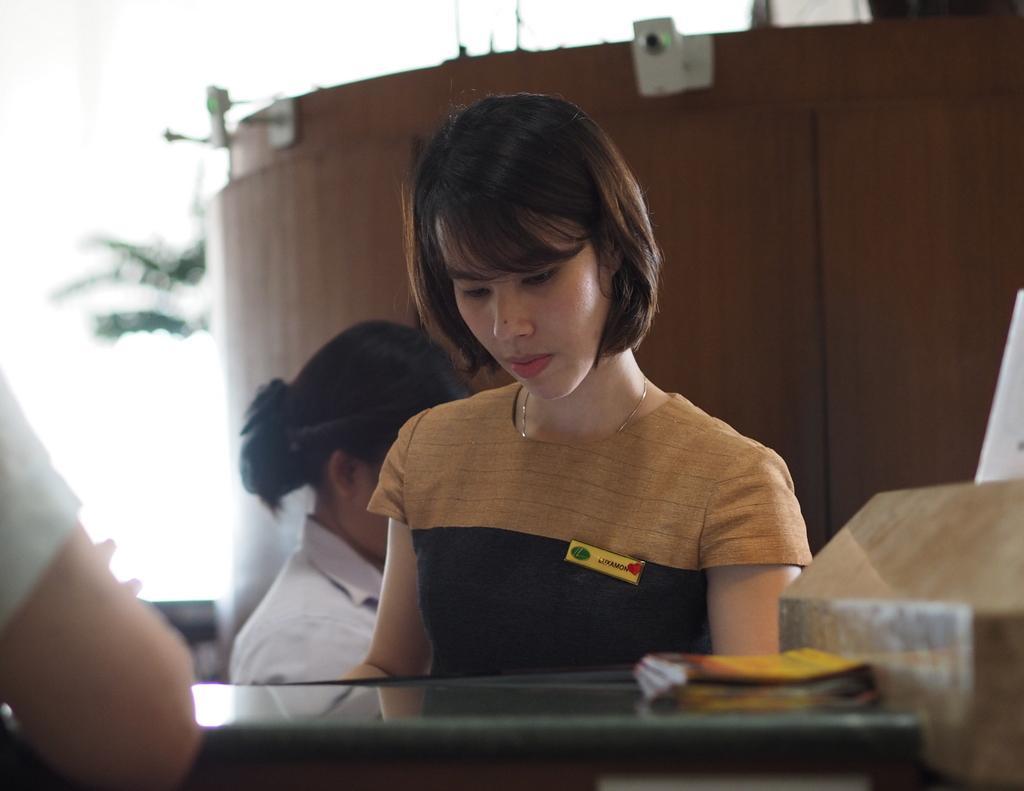Please provide a concise description of this image. This picture describes about few people, in the middle of the given image in front of a woman we can see a book on the table, in the background we can see couple of plants. 